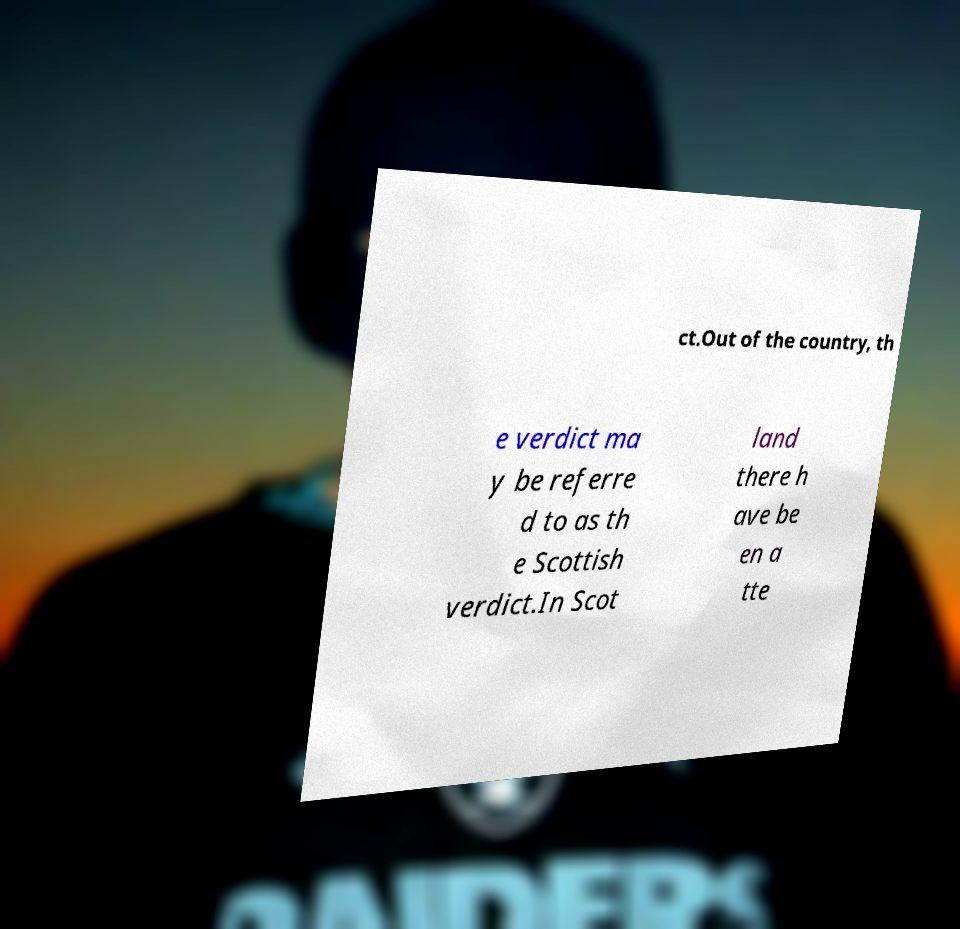Please read and relay the text visible in this image. What does it say? ct.Out of the country, th e verdict ma y be referre d to as th e Scottish verdict.In Scot land there h ave be en a tte 